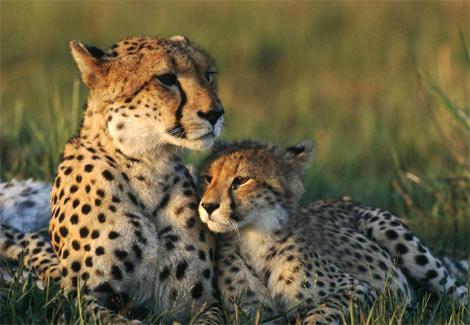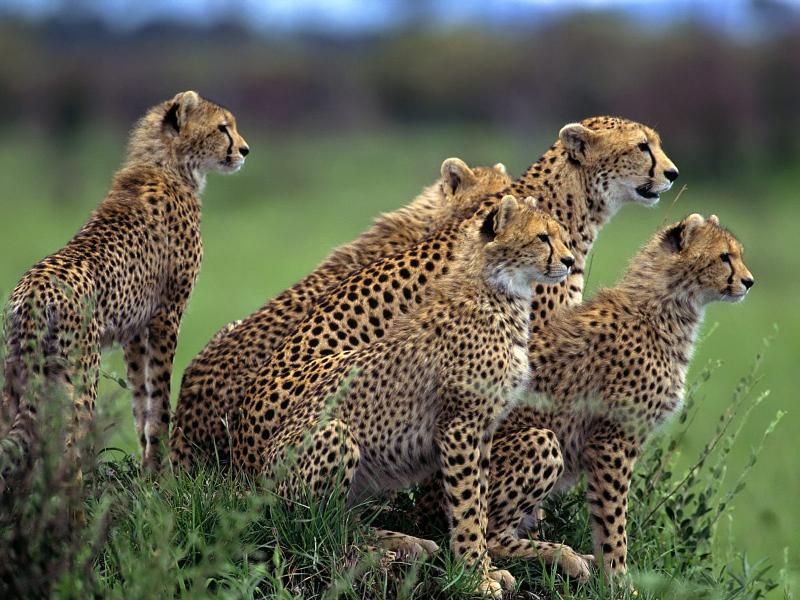The first image is the image on the left, the second image is the image on the right. For the images shown, is this caption "There are no more than three animals in one of the images." true? Answer yes or no. Yes. 